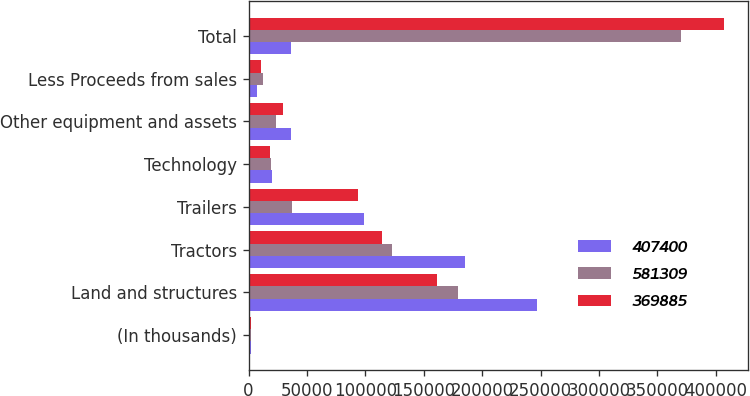Convert chart. <chart><loc_0><loc_0><loc_500><loc_500><stacked_bar_chart><ecel><fcel>(In thousands)<fcel>Land and structures<fcel>Tractors<fcel>Trailers<fcel>Technology<fcel>Other equipment and assets<fcel>Less Proceeds from sales<fcel>Total<nl><fcel>407400<fcel>2018<fcel>247291<fcel>185209<fcel>98835<fcel>20309<fcel>36648<fcel>6983<fcel>36648<nl><fcel>581309<fcel>2017<fcel>179150<fcel>123152<fcel>37424<fcel>19329<fcel>23070<fcel>12240<fcel>369885<nl><fcel>369885<fcel>2016<fcel>161646<fcel>114166<fcel>94040<fcel>18428<fcel>29661<fcel>10541<fcel>407400<nl></chart> 